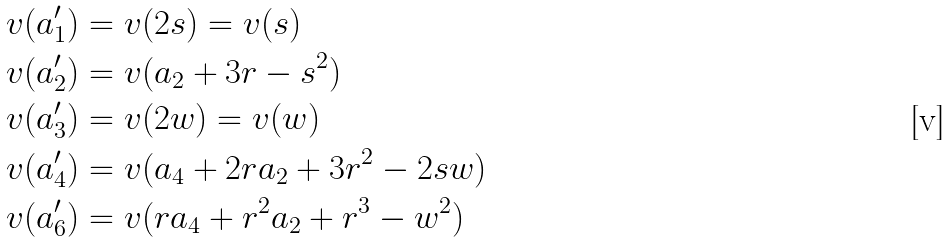<formula> <loc_0><loc_0><loc_500><loc_500>v ( a _ { 1 } ^ { \prime } ) & = v ( 2 s ) = v ( s ) \\ v ( a _ { 2 } ^ { \prime } ) & = v ( a _ { 2 } + 3 r - s ^ { 2 } ) \\ v ( a _ { 3 } ^ { \prime } ) & = v ( 2 w ) = v ( w ) \\ v ( a _ { 4 } ^ { \prime } ) & = v ( a _ { 4 } + 2 r a _ { 2 } + 3 r ^ { 2 } - 2 s w ) \\ v ( a _ { 6 } ^ { \prime } ) & = v ( r a _ { 4 } + r ^ { 2 } a _ { 2 } + r ^ { 3 } - w ^ { 2 } )</formula> 